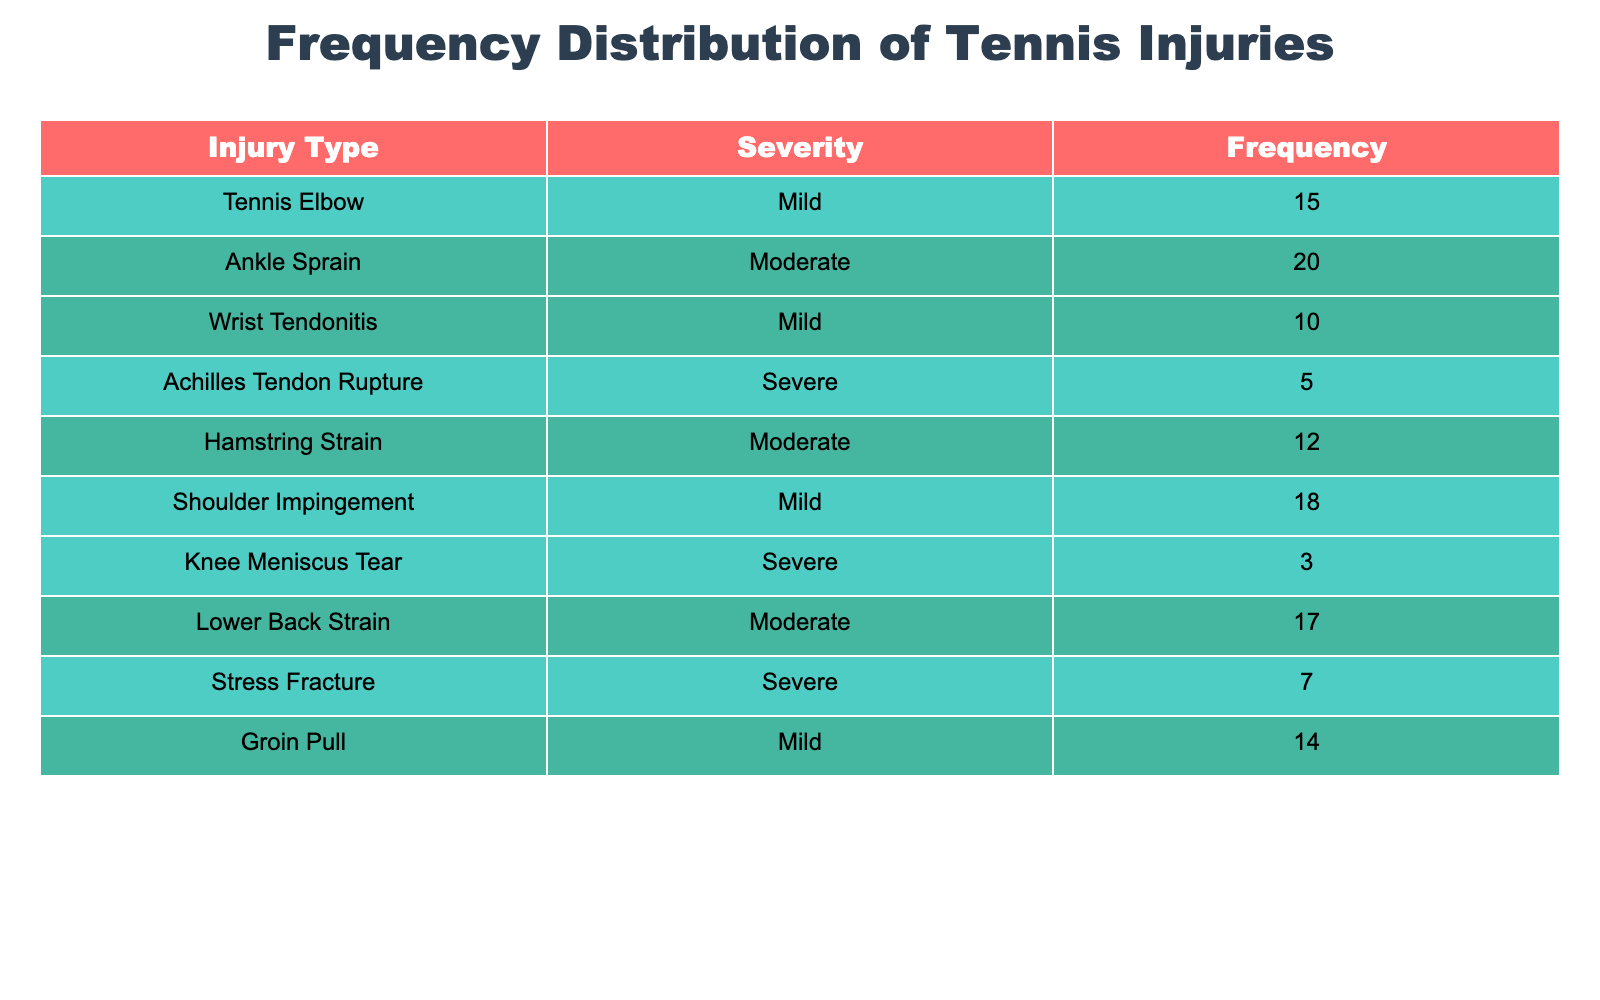What is the most common mild injury listed in the table? The table shows that "Tennis Elbow" has a frequency of 15, "Wrist Tendonitis" has a frequency of 10, "Shoulder Impingement" has a frequency of 18, and "Groin Pull" has a frequency of 14. Among these, "Shoulder Impingement" has the highest frequency.
Answer: Shoulder Impingement How many moderate injuries are listed in the table? The table lists three moderate injuries: "Ankle Sprain" (20), "Hamstring Strain" (12), and "Lower Back Strain" (17). Therefore, the number of moderate injuries is three.
Answer: 3 Is there any severe injury with a frequency greater than 5? The severe injuries listed are "Achilles Tendon Rupture" (5), "Knee Meniscus Tear" (3), and "Stress Fracture" (7). "Stress Fracture" is the only severe injury with a frequency greater than 5, confirming that there is one competent answer for this question.
Answer: Yes What is the total frequency of mild injuries? The frequencies for mild injuries are 15 (Tennis Elbow), 10 (Wrist Tendonitis), 18 (Shoulder Impingement), and 14 (Groin Pull). Adding these (15 + 10 + 18 + 14) gives 57.
Answer: 57 Which severity category has the least total frequency? Calculating the total frequency for each severity: Mild (57), Moderate (49 sum of: 20, 12, 17), and Severe (15 sum of: 5, 3, 7). The least total frequency belongs to "Severe" with 15.
Answer: Severe What is the average frequency of moderate injuries? The frequencies for moderate injuries are 20 (Ankle Sprain), 12 (Hamstring Strain), and 17 (Lower Back Strain). First, sum these three (20 + 12 + 17 = 49) and then divide by the number of injuries (3). The average is 49/3 = 16.33.
Answer: 16.33 How many total injuries are categorized as severe? The table lists three severe injuries: "Achilles Tendon Rupture," "Knee Meniscus Tear," and "Stress Fracture." Hence, the total is three severe injuries.
Answer: 3 What is the difference in frequency between the most and least frequent injuries? The most frequent injury is "Shoulder Impingement" (18), and the least frequent is "Knee Meniscus Tear" (3). The difference is calculated as 18 - 3 = 15.
Answer: 15 Which injury type has the highest overall frequency? The highest frequency among all injuries is "Ankle Sprain," which has a frequency of 20. No other injury type exceeds this frequency, confirming that "Ankle Sprain" stands out.
Answer: Ankle Sprain 